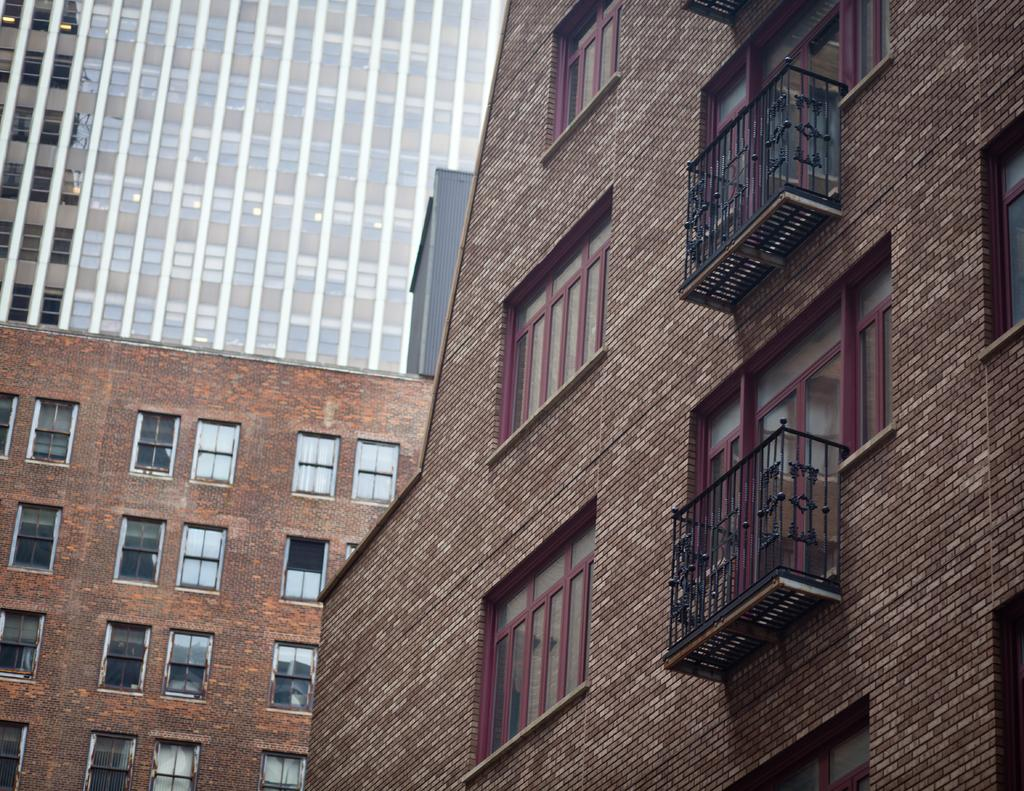What type of structures can be seen in the image? There are buildings in the image. Is there a wine cellar in the jail that can be seen in the image? There is no mention of a jail or wine cellar in the image, as the only fact provided is that there are buildings. 